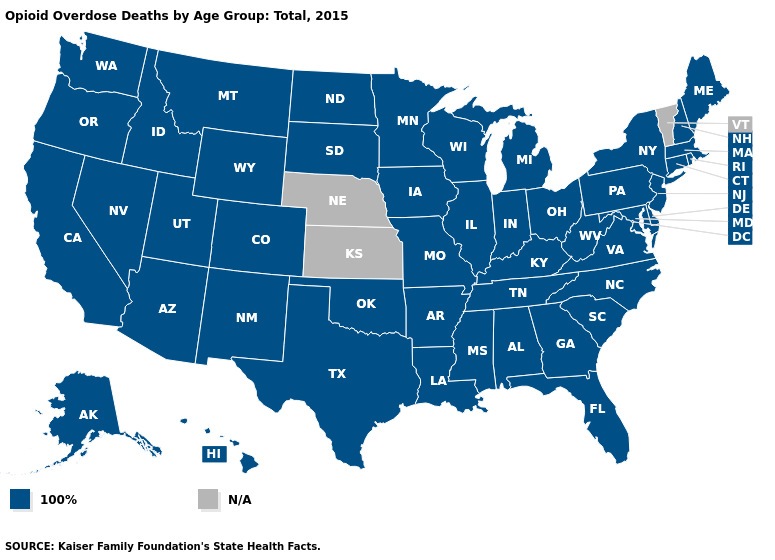Name the states that have a value in the range 100%?
Quick response, please. Alabama, Alaska, Arizona, Arkansas, California, Colorado, Connecticut, Delaware, Florida, Georgia, Hawaii, Idaho, Illinois, Indiana, Iowa, Kentucky, Louisiana, Maine, Maryland, Massachusetts, Michigan, Minnesota, Mississippi, Missouri, Montana, Nevada, New Hampshire, New Jersey, New Mexico, New York, North Carolina, North Dakota, Ohio, Oklahoma, Oregon, Pennsylvania, Rhode Island, South Carolina, South Dakota, Tennessee, Texas, Utah, Virginia, Washington, West Virginia, Wisconsin, Wyoming. Name the states that have a value in the range 100%?
Quick response, please. Alabama, Alaska, Arizona, Arkansas, California, Colorado, Connecticut, Delaware, Florida, Georgia, Hawaii, Idaho, Illinois, Indiana, Iowa, Kentucky, Louisiana, Maine, Maryland, Massachusetts, Michigan, Minnesota, Mississippi, Missouri, Montana, Nevada, New Hampshire, New Jersey, New Mexico, New York, North Carolina, North Dakota, Ohio, Oklahoma, Oregon, Pennsylvania, Rhode Island, South Carolina, South Dakota, Tennessee, Texas, Utah, Virginia, Washington, West Virginia, Wisconsin, Wyoming. Name the states that have a value in the range 100%?
Answer briefly. Alabama, Alaska, Arizona, Arkansas, California, Colorado, Connecticut, Delaware, Florida, Georgia, Hawaii, Idaho, Illinois, Indiana, Iowa, Kentucky, Louisiana, Maine, Maryland, Massachusetts, Michigan, Minnesota, Mississippi, Missouri, Montana, Nevada, New Hampshire, New Jersey, New Mexico, New York, North Carolina, North Dakota, Ohio, Oklahoma, Oregon, Pennsylvania, Rhode Island, South Carolina, South Dakota, Tennessee, Texas, Utah, Virginia, Washington, West Virginia, Wisconsin, Wyoming. What is the value of New Hampshire?
Concise answer only. 100%. Which states have the highest value in the USA?
Short answer required. Alabama, Alaska, Arizona, Arkansas, California, Colorado, Connecticut, Delaware, Florida, Georgia, Hawaii, Idaho, Illinois, Indiana, Iowa, Kentucky, Louisiana, Maine, Maryland, Massachusetts, Michigan, Minnesota, Mississippi, Missouri, Montana, Nevada, New Hampshire, New Jersey, New Mexico, New York, North Carolina, North Dakota, Ohio, Oklahoma, Oregon, Pennsylvania, Rhode Island, South Carolina, South Dakota, Tennessee, Texas, Utah, Virginia, Washington, West Virginia, Wisconsin, Wyoming. Which states have the highest value in the USA?
Answer briefly. Alabama, Alaska, Arizona, Arkansas, California, Colorado, Connecticut, Delaware, Florida, Georgia, Hawaii, Idaho, Illinois, Indiana, Iowa, Kentucky, Louisiana, Maine, Maryland, Massachusetts, Michigan, Minnesota, Mississippi, Missouri, Montana, Nevada, New Hampshire, New Jersey, New Mexico, New York, North Carolina, North Dakota, Ohio, Oklahoma, Oregon, Pennsylvania, Rhode Island, South Carolina, South Dakota, Tennessee, Texas, Utah, Virginia, Washington, West Virginia, Wisconsin, Wyoming. Which states have the lowest value in the USA?
Concise answer only. Alabama, Alaska, Arizona, Arkansas, California, Colorado, Connecticut, Delaware, Florida, Georgia, Hawaii, Idaho, Illinois, Indiana, Iowa, Kentucky, Louisiana, Maine, Maryland, Massachusetts, Michigan, Minnesota, Mississippi, Missouri, Montana, Nevada, New Hampshire, New Jersey, New Mexico, New York, North Carolina, North Dakota, Ohio, Oklahoma, Oregon, Pennsylvania, Rhode Island, South Carolina, South Dakota, Tennessee, Texas, Utah, Virginia, Washington, West Virginia, Wisconsin, Wyoming. What is the value of Montana?
Quick response, please. 100%. Name the states that have a value in the range N/A?
Give a very brief answer. Kansas, Nebraska, Vermont. What is the value of Kansas?
Short answer required. N/A. 